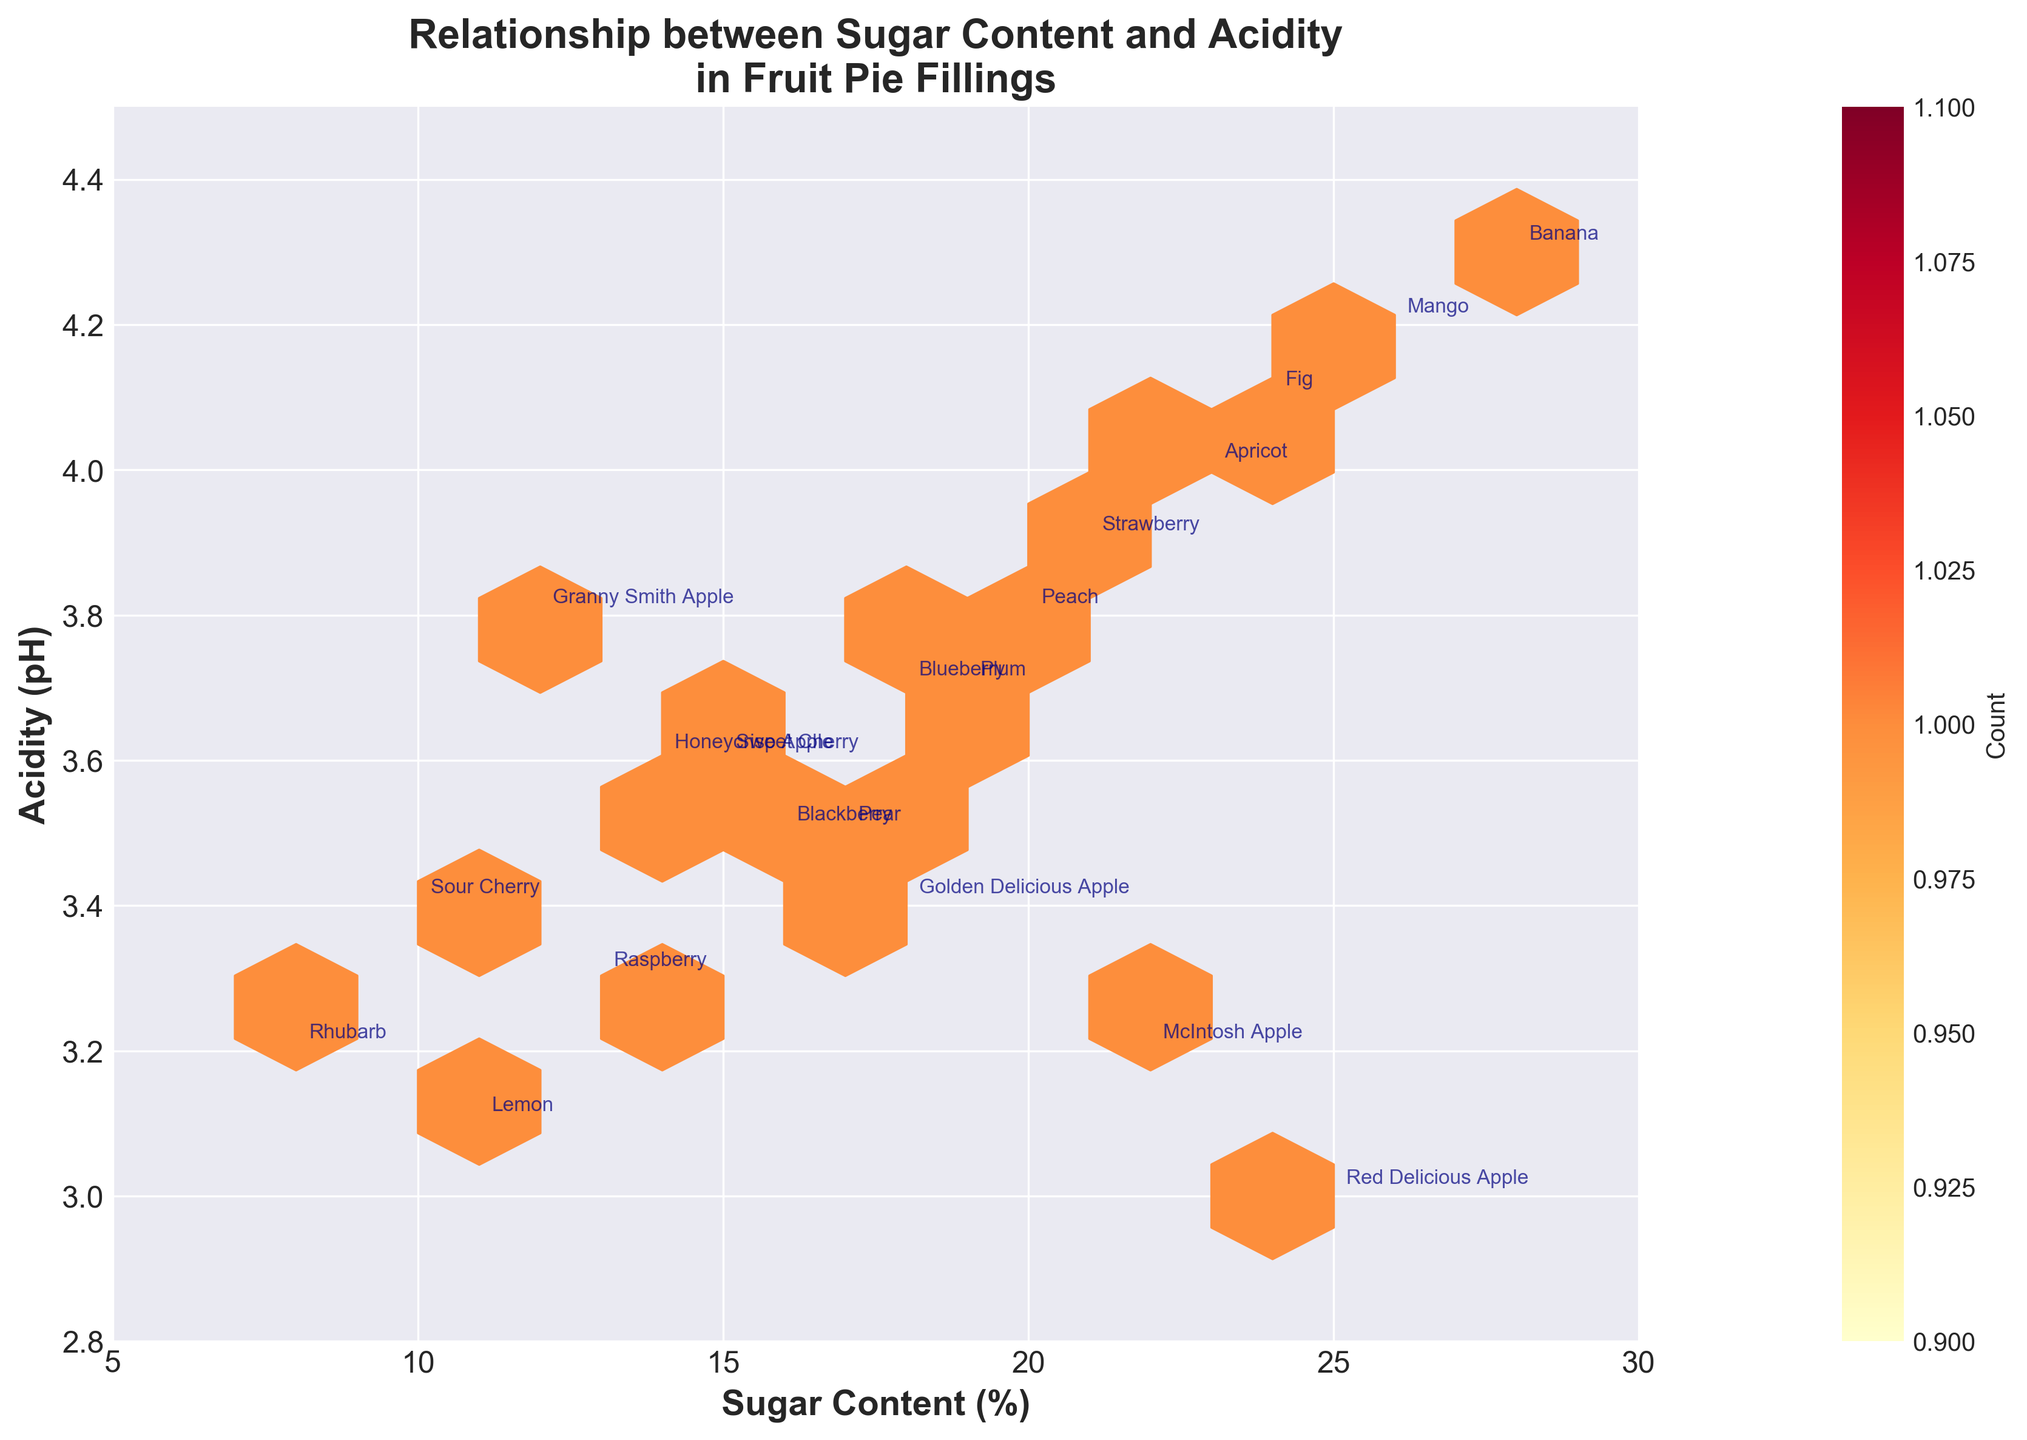What's the relationship between sugar content and acidity in fruit pie fillings? The plot shows a hexbin plot with sugar content on the x-axis and acidity on the y-axis. The hexbin plot indicates a negative correlation between sugar content and acidity, meaning that as sugar content increases, acidity decreases.
Answer: Negative correlation What is the title of the plot? The title of the plot is displayed at the top.
Answer: Relationship between Sugar Content and Acidity in Fruit Pie Fillings How many data points have been counted within each hexagon? This information is depicted by the color intensity in the hexbin plot, where lighter colors represent fewer data points and darker colors represent more data points.
Answer: Between 1 and more (the legend shows count but not precise numbers) Which fruit variety has the highest sugar content and what is the acidity level of this fruit? The highest sugar content can be identified by finding the rightmost point on the x-axis. For the corresponding point, read off its position on the y-axis to get the acidity level.
Answer: Banana, 4.3 pH Which fruit variety has the lowest acidity level, and what's its sugar content? The lowest acidity level can be identified by finding the lowermost point on the y-axis. For the corresponding point, read off its position on the x-axis to get the sugar content.
Answer: Red Delicious Apple, 25% What is the fruit variety with the same sugar content as Peaches but lower acidity? Find the position of the Peach data point (20% sugar, 3.8 pH) and look for another data point on the same x-level (20%) but lower on the y-axis. A matching point is found around (20%, 3.7 pH).
Answer: Plum How does the acidity of Granny Smith Apples compare to McIntosh Apples? Locate the points for Granny Smith Apple (12% sugar, 3.8 pH) and McIntosh Apple (22% sugar, 3.2 pH) and compare their y-values (acidity levels).
Answer: Higher in Granny Smith Apples What are the sugar content levels for fruits with acidity levels of 3.1 and 3.2? Identify the points located at 3.1 pH and 3.2 pH on the y-axis and record the sugar levels. Lemons are at 3.1 and Rhubarb is at 3.2.
Answer: Lemon: 11%; Rhubarb: 8% Which fruit variety has a sugar content close to 24% and what is its acidity level? Find the approximate position on the x-axis that is close to 24% sugar content and read off the corresponding y-value.
Answer: Fig, 4.1 pH Do fruits with higher sugar content generally have higher acidity in this dataset? By observing the overall downward trend in the hexbin plot, it is apparent that higher sugar content is generally associated with lower acidity.
Answer: No 